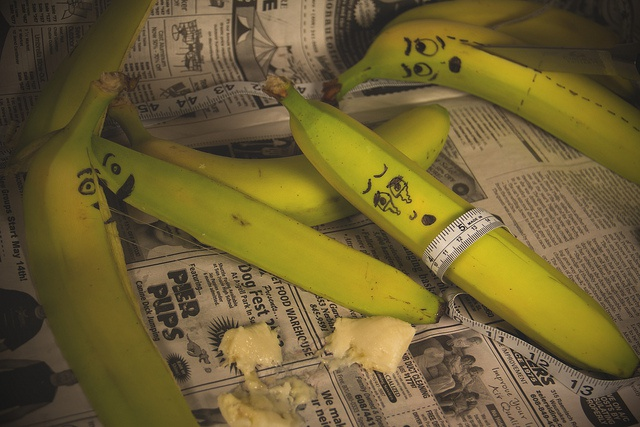Describe the objects in this image and their specific colors. I can see banana in black and olive tones, banana in black and olive tones, banana in black, olive, and gold tones, banana in black and olive tones, and knife in black, darkgreen, and olive tones in this image. 